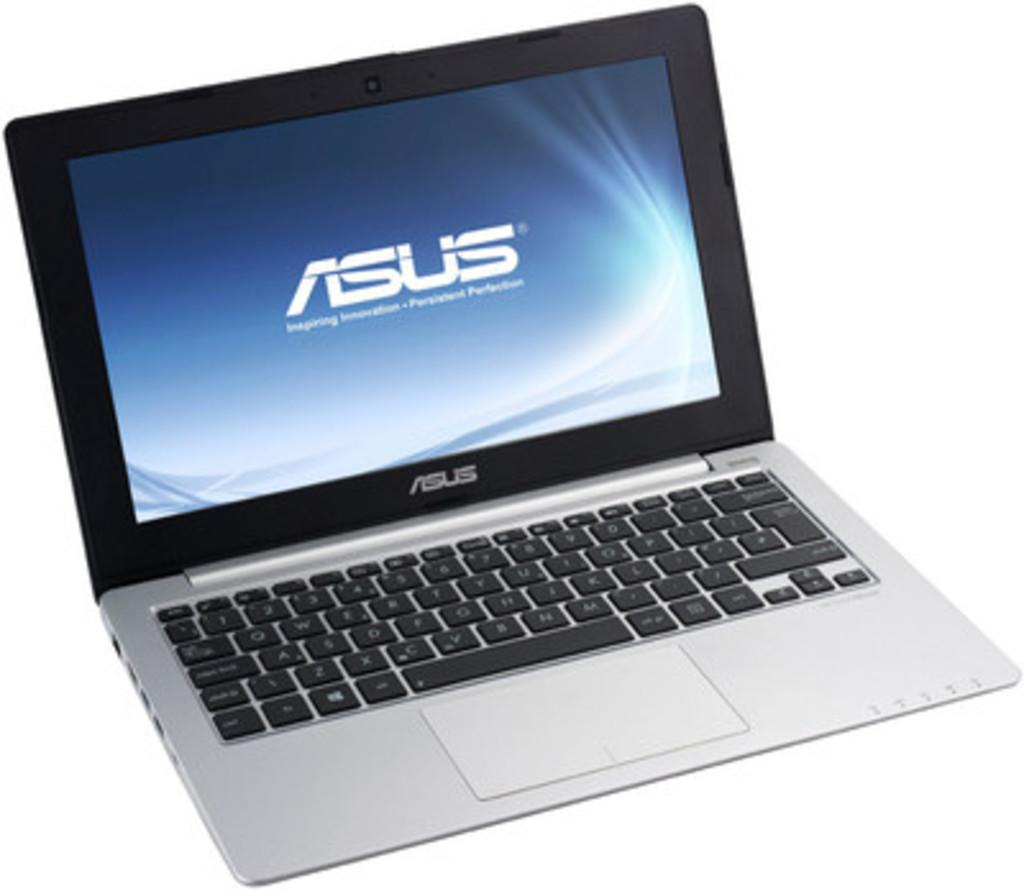<image>
Offer a succinct explanation of the picture presented. A laptop ad for the Asus Laptop that shows a thin computer and looks nice 